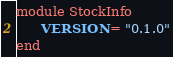Convert code to text. <code><loc_0><loc_0><loc_500><loc_500><_Ruby_>module StockInfo
      VERSION = "0.1.0"
end
</code> 